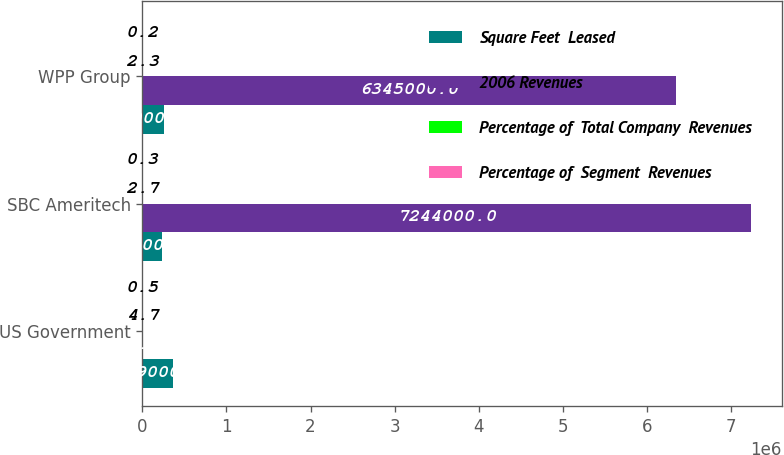<chart> <loc_0><loc_0><loc_500><loc_500><stacked_bar_chart><ecel><fcel>US Government<fcel>SBC Ameritech<fcel>WPP Group<nl><fcel>Square Feet  Leased<fcel>359000<fcel>234000<fcel>260000<nl><fcel>2006 Revenues<fcel>4.7<fcel>7.244e+06<fcel>6.345e+06<nl><fcel>Percentage of  Total Company  Revenues<fcel>4.7<fcel>2.7<fcel>2.3<nl><fcel>Percentage of  Segment  Revenues<fcel>0.5<fcel>0.3<fcel>0.2<nl></chart> 